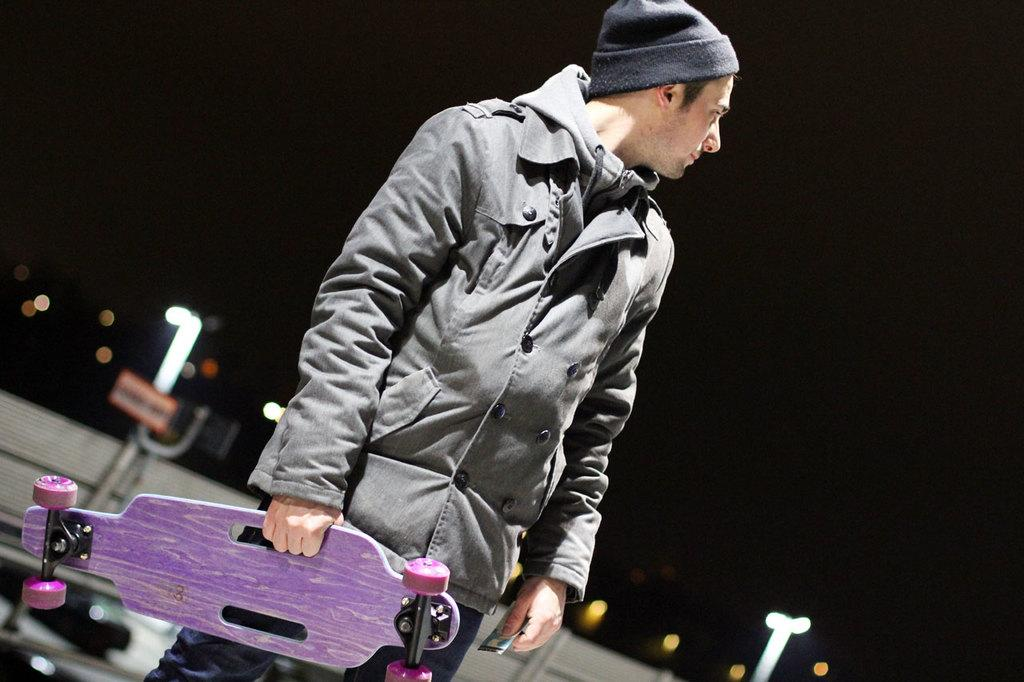What is the person in the image doing? The person is standing in the image. What object is the person holding? The person is holding a skateboard. What type of clothing is the person wearing? The person is wearing a gray jacket. What can be seen in the background of the image? There are lights visible in the background of the image. What type of plough is being used by the person in the image? There is no plough present in the image; the person is holding a skateboard. What is the person saying in the image? The image does not include any audio or text, so it is impossible to determine what the person might be saying. 